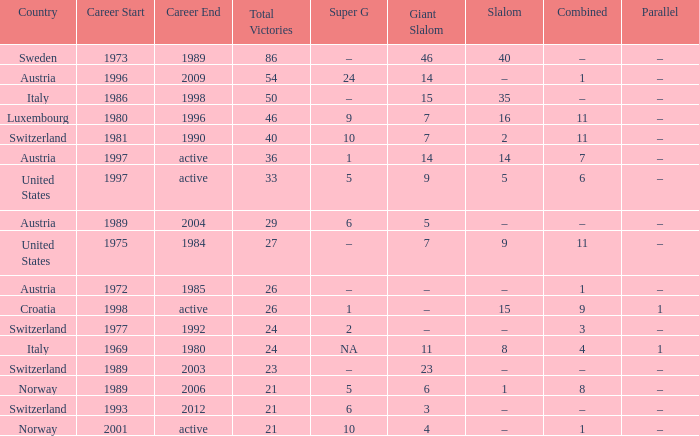What Giant Slalom has Victories larger than 27, a Slalom of –, and a Career of 1996–2009? 14.0. 